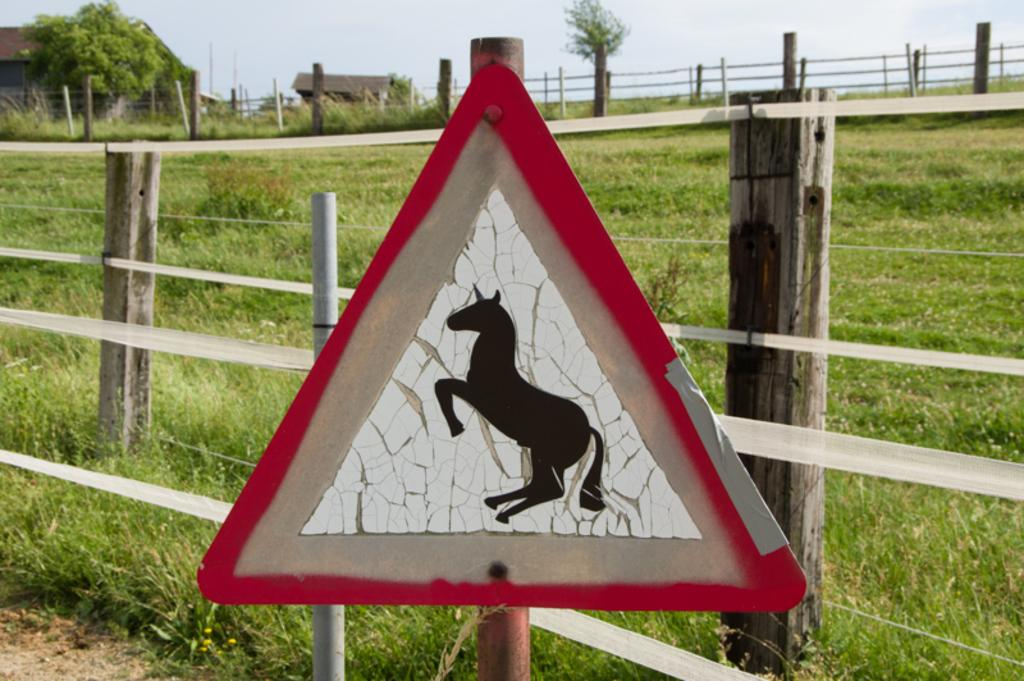What is the main object in the image? A: There is a board in the image. What is depicted on the board? The board contains a picture of an animal. What can be seen in the background of the image? There is a fence, grass, trees, houses, and the sky visible in the background of the image. What arithmetic problem is being solved on the board in the image? There is no arithmetic problem visible on the board in the image; it contains a picture of an animal. Is there any water visible in the image? There is no water visible in the image; it features a board with an animal picture, a fence, grass, trees, houses, and the sky. 